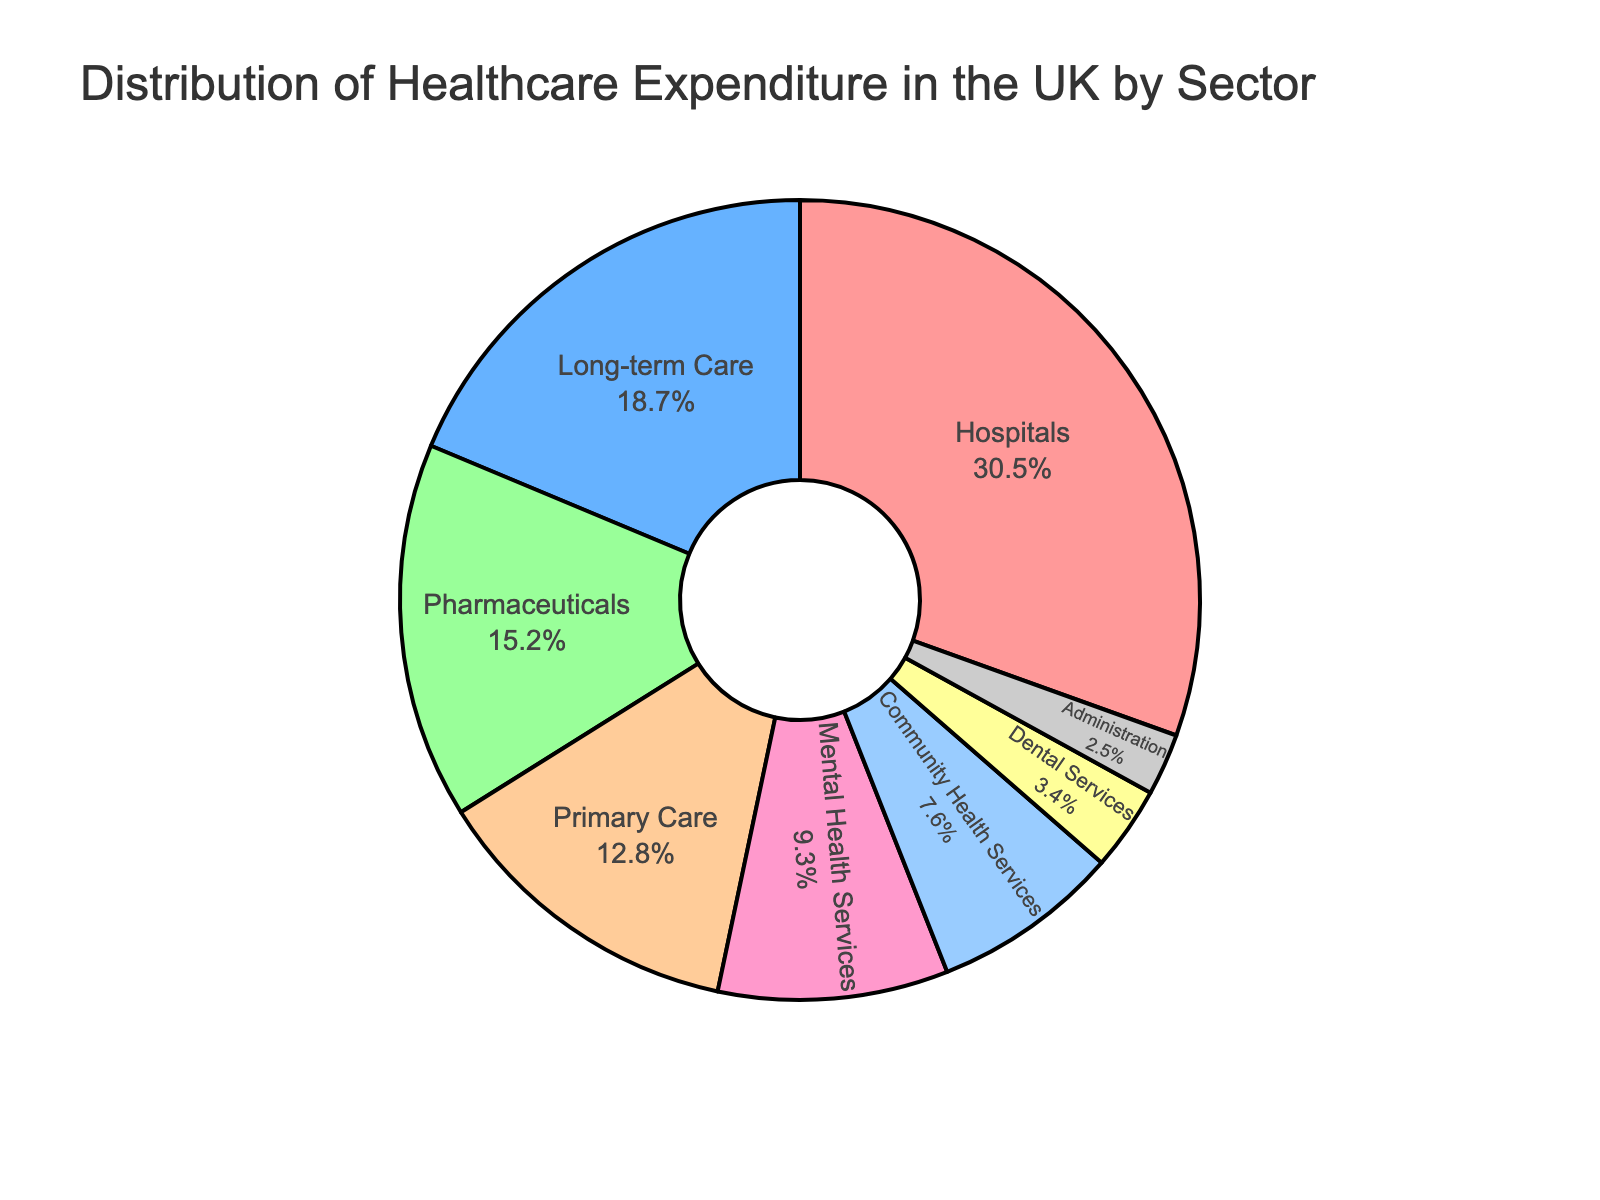What sector accounts for the largest portion of healthcare expenditure? The largest portion is represented by the largest slice in the pie chart. This slice is labeled "Hospitals" and represents 30.5% of the total expenditure.
Answer: Hospitals What is the combined expenditure percentage for Pharmaceuticals and Primary Care? Locate the slices for "Pharmaceuticals" and "Primary Care" in the pie chart. Pharmaceuticals account for 15.2% and Primary Care for 12.8%. Add these two percentages together: 15.2% + 12.8% = 28.0%.
Answer: 28.0% Which sector has the smallest share of healthcare expenditure? Identify the smallest slice in the pie chart. The smallest slice is labeled "Administration" and represents 2.5% of the total expenditure.
Answer: Administration How much higher is the expenditure on Mental Health Services compared to Dental Services? Locate the slices for "Mental Health Services" and "Dental Services." Mental Health Services account for 9.3% while Dental Services account for 3.4%. Subtract the smaller percentage from the larger one: 9.3% - 3.4% = 5.9%.
Answer: 5.9% What sectors make up over half of the total healthcare expenditure when combined? Identify the largest slices and sum their percentages until the total exceeds 50%. Hospitals (30.5%), Long-term Care (18.7%), and Pharmaceuticals (15.2%) sum up to 64.4%, which exceeds half.
Answer: Hospitals, Long-term Care, Pharmaceuticals How does the expenditure on Community Health Services compare to that on Dental Services? Locate the slices for "Community Health Services" and "Dental Services." Community Health Services account for 7.6%, while Dental Services account for 3.4%. Compare the percentages: 7.6% is greater than 3.4%.
Answer: Community Health Services have higher expenditure Which sectors have a combined expenditure less than the expenditure on Hospitals alone? Identify slices other than Hospitals and sum the percentages of smaller slices until the total is less than 30.5%. Community Health Services (7.6%), Dental Services (3.4%), and Administration (2.5%) sum to 13.5%, which is less than 30.5%.
Answer: Community Health Services, Dental Services, Administration What is the difference in expenditure percentage between Long-term Care and Primary Care? Locate the slices for "Long-term Care" and "Primary Care." Long-term Care accounts for 18.7% and Primary Care for 12.8%. Subtract the smaller percentage from the larger one: 18.7% - 12.8% = 5.9%.
Answer: 5.9% What percentage of the total expenditure is spent on sectors other than Hospitals and Long-term Care? First, add the percentages for Hospitals and Long-term Care: 30.5% + 18.7% = 49.2%. Subtract this sum from 100% to find the expenditure on all other sectors: 100% - 49.2% = 50.8%.
Answer: 50.8% 